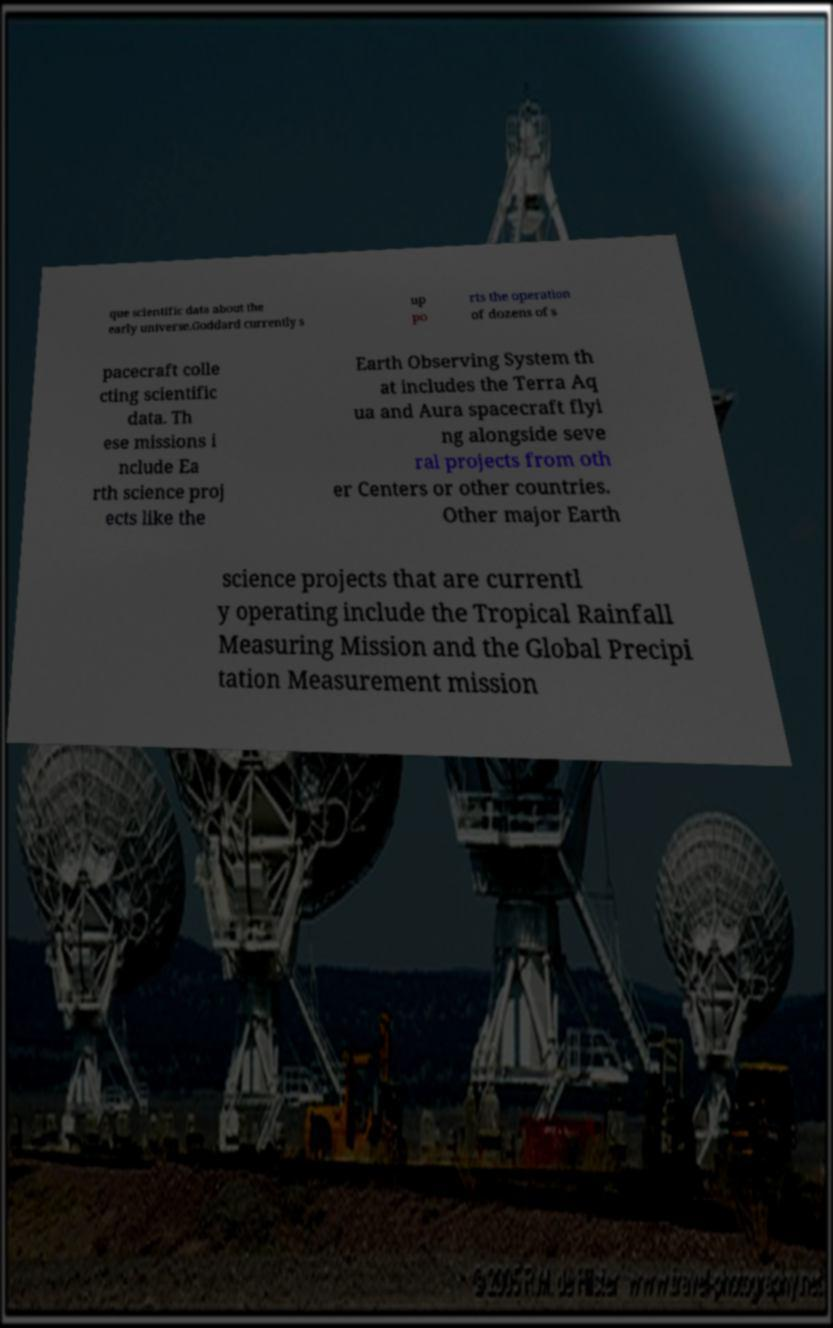Could you extract and type out the text from this image? que scientific data about the early universe.Goddard currently s up po rts the operation of dozens of s pacecraft colle cting scientific data. Th ese missions i nclude Ea rth science proj ects like the Earth Observing System th at includes the Terra Aq ua and Aura spacecraft flyi ng alongside seve ral projects from oth er Centers or other countries. Other major Earth science projects that are currentl y operating include the Tropical Rainfall Measuring Mission and the Global Precipi tation Measurement mission 